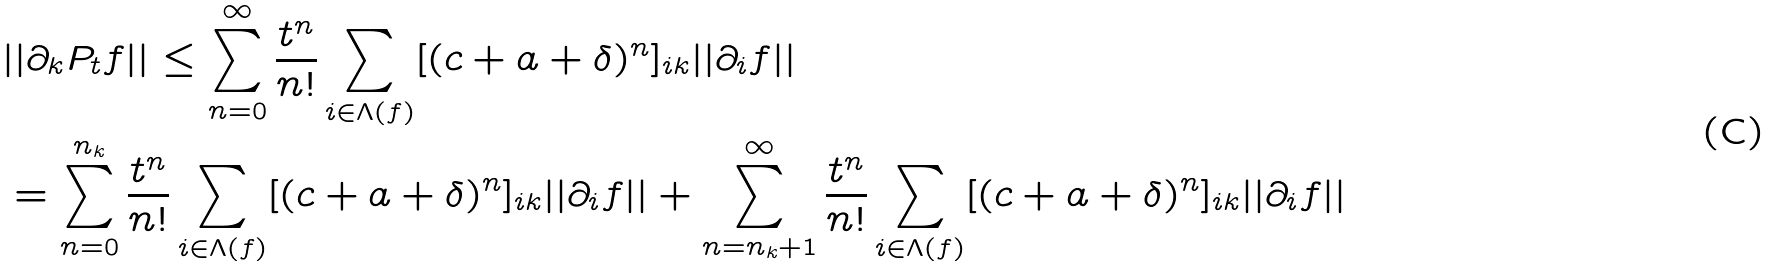<formula> <loc_0><loc_0><loc_500><loc_500>& | | \partial _ { k } P _ { t } f | | \leq \sum _ { n = 0 } ^ { \infty } \frac { t ^ { n } } { n ! } \sum _ { i \in \Lambda ( f ) } [ ( c + a + \delta ) ^ { n } ] _ { i k } | | \partial _ { i } f | | \\ & = \sum _ { n = 0 } ^ { n _ { k } } \frac { t ^ { n } } { n ! } \sum _ { i \in \Lambda ( f ) } [ ( c + a + \delta ) ^ { n } ] _ { i k } | | \partial _ { i } f | | + \sum _ { n = n _ { k } + 1 } ^ { \infty } \frac { t ^ { n } } { n ! } \sum _ { i \in \Lambda ( f ) } [ ( c + a + \delta ) ^ { n } ] _ { i k } | | \partial _ { i } f | |</formula> 